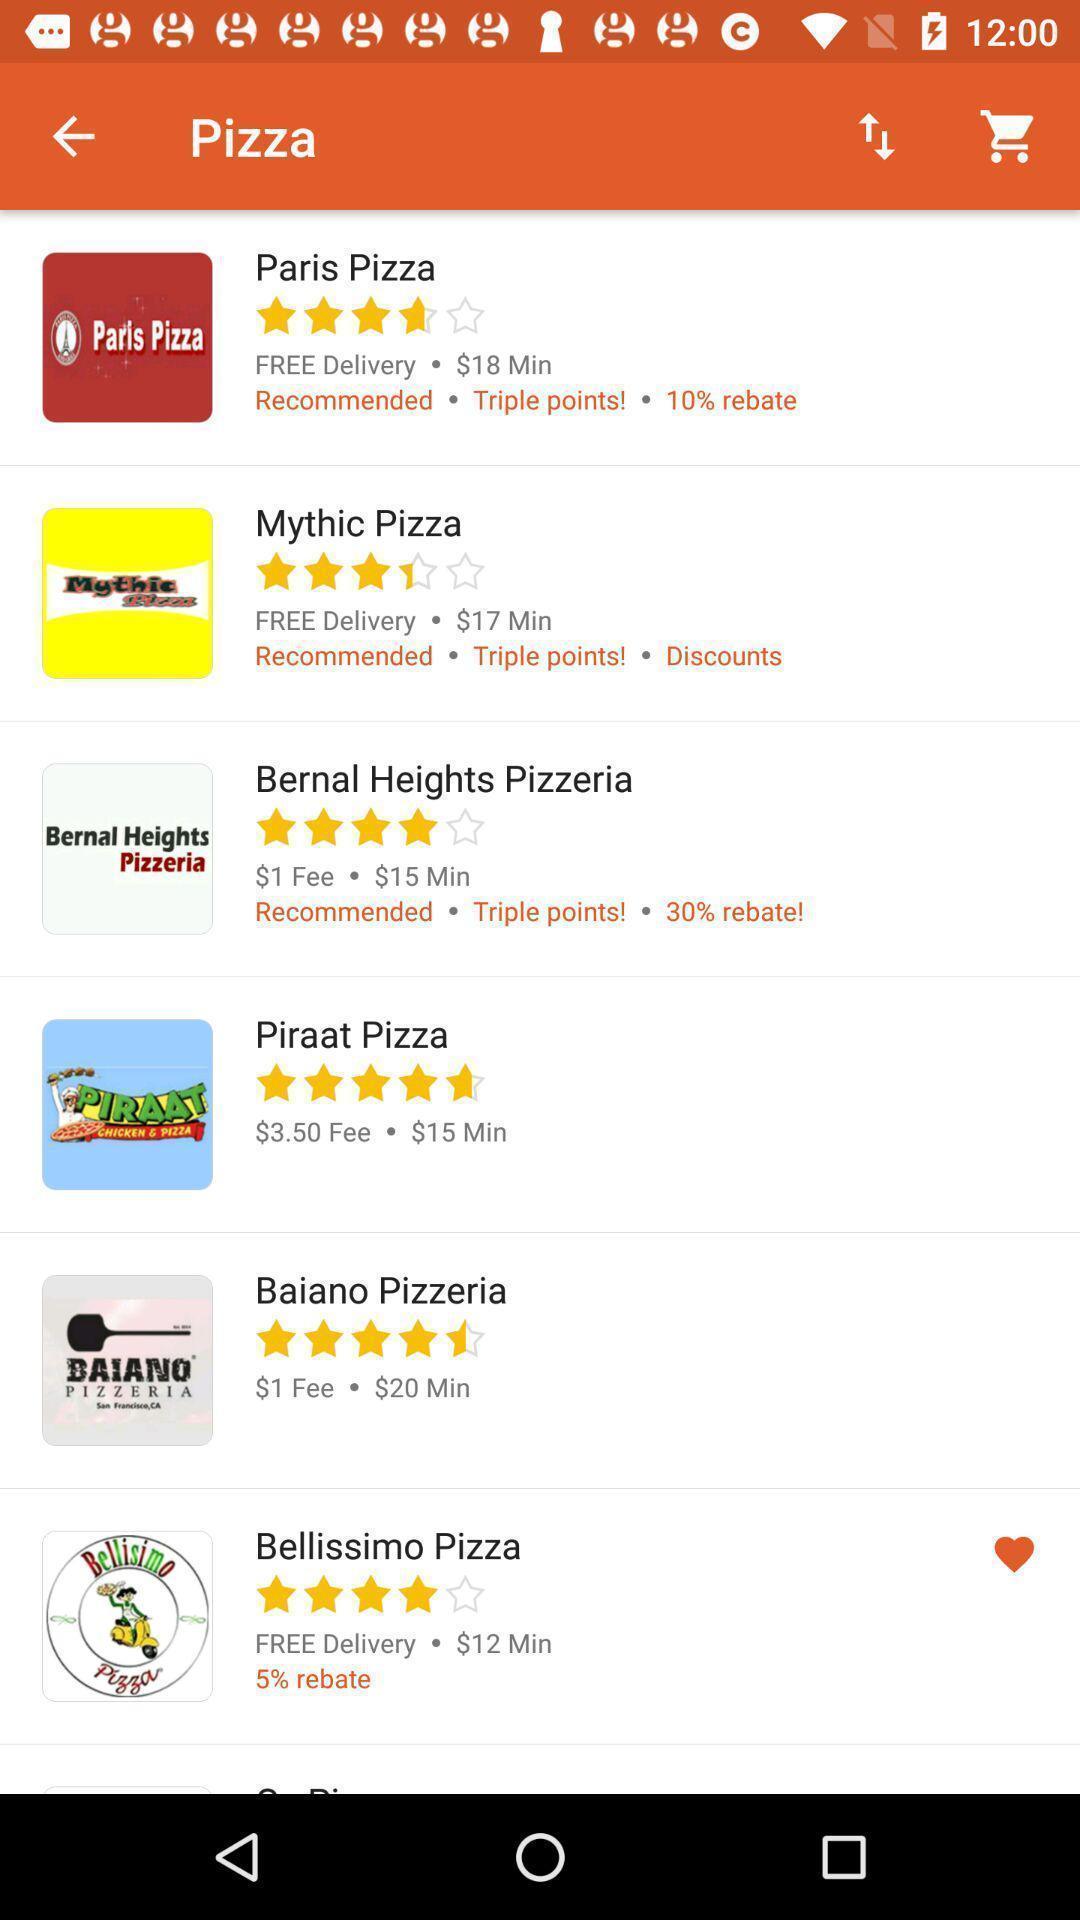Give me a narrative description of this picture. Page showing list of pizza stores. 